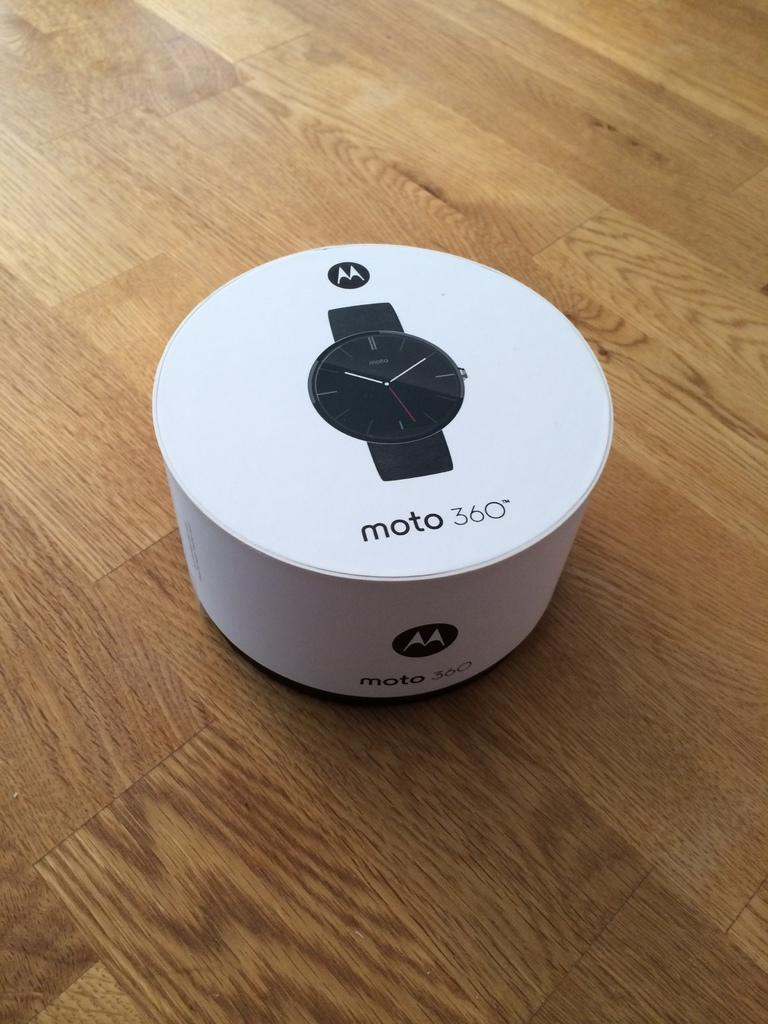<image>
Render a clear and concise summary of the photo. A moto 360 smart watch package is sitting on a wooden floor. 